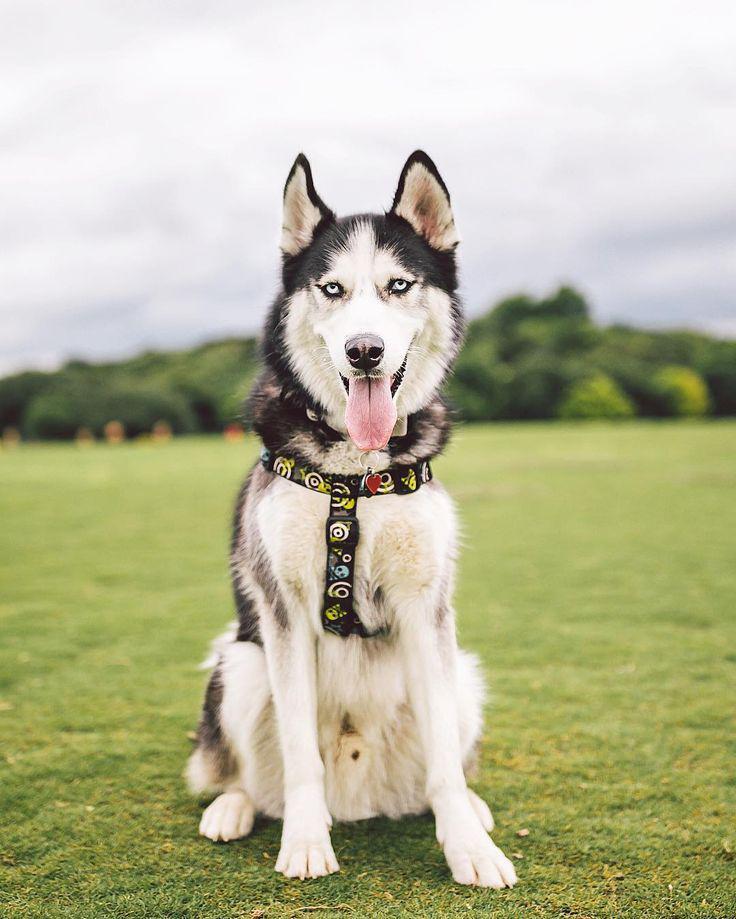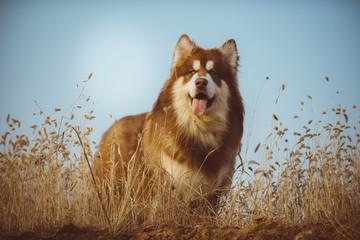The first image is the image on the left, the second image is the image on the right. For the images displayed, is the sentence "Each dog has an open mouth and one dog is wearing a harness." factually correct? Answer yes or no. Yes. The first image is the image on the left, the second image is the image on the right. For the images shown, is this caption "The left and right image contains the same number of dogs with one sitting and the other standing outside." true? Answer yes or no. Yes. 